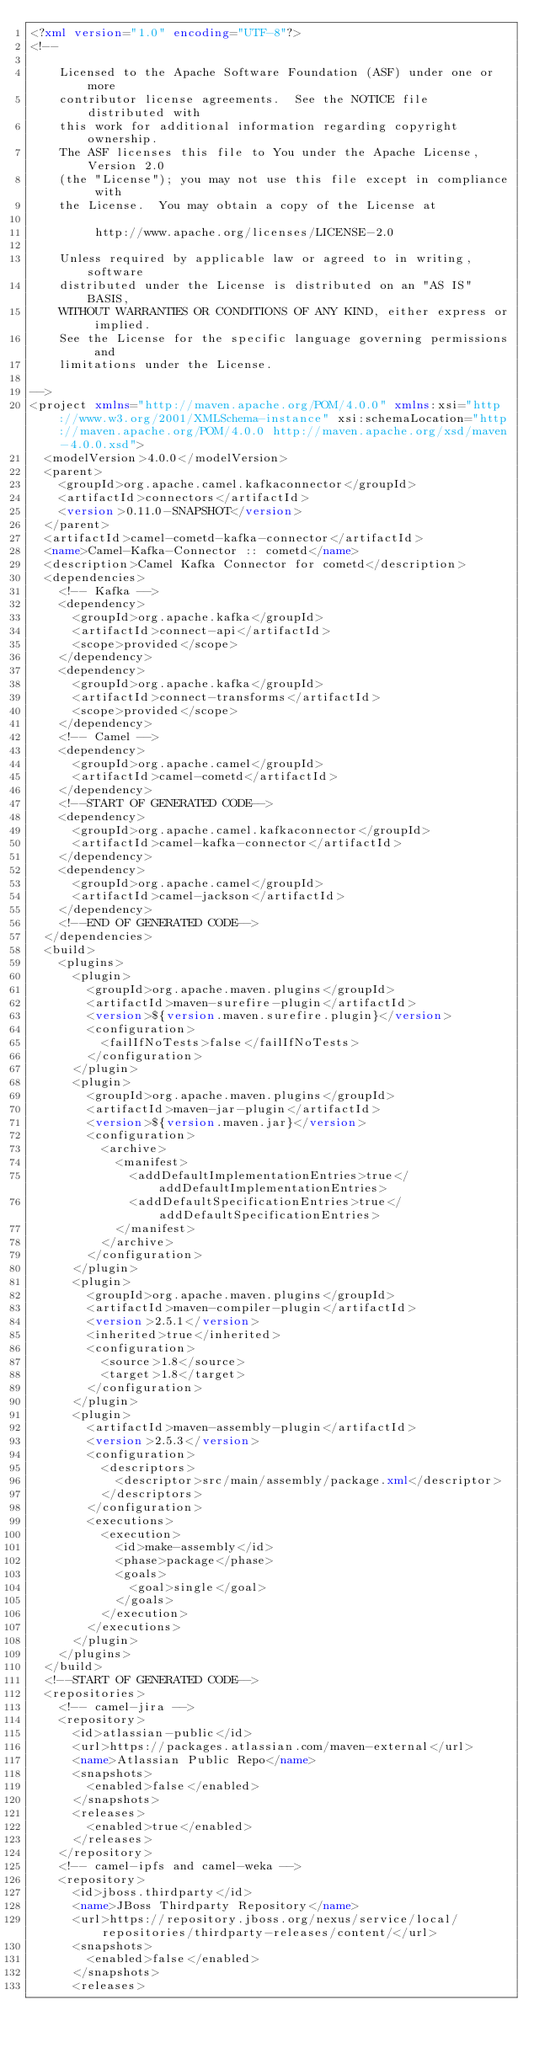Convert code to text. <code><loc_0><loc_0><loc_500><loc_500><_XML_><?xml version="1.0" encoding="UTF-8"?>
<!--

    Licensed to the Apache Software Foundation (ASF) under one or more
    contributor license agreements.  See the NOTICE file distributed with
    this work for additional information regarding copyright ownership.
    The ASF licenses this file to You under the Apache License, Version 2.0
    (the "License"); you may not use this file except in compliance with
    the License.  You may obtain a copy of the License at

         http://www.apache.org/licenses/LICENSE-2.0

    Unless required by applicable law or agreed to in writing, software
    distributed under the License is distributed on an "AS IS" BASIS,
    WITHOUT WARRANTIES OR CONDITIONS OF ANY KIND, either express or implied.
    See the License for the specific language governing permissions and
    limitations under the License.

-->
<project xmlns="http://maven.apache.org/POM/4.0.0" xmlns:xsi="http://www.w3.org/2001/XMLSchema-instance" xsi:schemaLocation="http://maven.apache.org/POM/4.0.0 http://maven.apache.org/xsd/maven-4.0.0.xsd">
  <modelVersion>4.0.0</modelVersion>
  <parent>
    <groupId>org.apache.camel.kafkaconnector</groupId>
    <artifactId>connectors</artifactId>
    <version>0.11.0-SNAPSHOT</version>
  </parent>
  <artifactId>camel-cometd-kafka-connector</artifactId>
  <name>Camel-Kafka-Connector :: cometd</name>
  <description>Camel Kafka Connector for cometd</description>
  <dependencies>
    <!-- Kafka -->
    <dependency>
      <groupId>org.apache.kafka</groupId>
      <artifactId>connect-api</artifactId>
      <scope>provided</scope>
    </dependency>
    <dependency>
      <groupId>org.apache.kafka</groupId>
      <artifactId>connect-transforms</artifactId>
      <scope>provided</scope>
    </dependency>
    <!-- Camel -->
    <dependency>
      <groupId>org.apache.camel</groupId>
      <artifactId>camel-cometd</artifactId>
    </dependency>
    <!--START OF GENERATED CODE-->
    <dependency>
      <groupId>org.apache.camel.kafkaconnector</groupId>
      <artifactId>camel-kafka-connector</artifactId>
    </dependency>
    <dependency>
      <groupId>org.apache.camel</groupId>
      <artifactId>camel-jackson</artifactId>
    </dependency>
    <!--END OF GENERATED CODE-->
  </dependencies>
  <build>
    <plugins>
      <plugin>
        <groupId>org.apache.maven.plugins</groupId>
        <artifactId>maven-surefire-plugin</artifactId>
        <version>${version.maven.surefire.plugin}</version>
        <configuration>
          <failIfNoTests>false</failIfNoTests>
        </configuration>
      </plugin>
      <plugin>
        <groupId>org.apache.maven.plugins</groupId>
        <artifactId>maven-jar-plugin</artifactId>
        <version>${version.maven.jar}</version>
        <configuration>
          <archive>
            <manifest>
              <addDefaultImplementationEntries>true</addDefaultImplementationEntries>
              <addDefaultSpecificationEntries>true</addDefaultSpecificationEntries>
            </manifest>
          </archive>
        </configuration>
      </plugin>
      <plugin>
        <groupId>org.apache.maven.plugins</groupId>
        <artifactId>maven-compiler-plugin</artifactId>
        <version>2.5.1</version>
        <inherited>true</inherited>
        <configuration>
          <source>1.8</source>
          <target>1.8</target>
        </configuration>
      </plugin>
      <plugin>
        <artifactId>maven-assembly-plugin</artifactId>
        <version>2.5.3</version>
        <configuration>
          <descriptors>
            <descriptor>src/main/assembly/package.xml</descriptor>
          </descriptors>
        </configuration>
        <executions>
          <execution>
            <id>make-assembly</id>
            <phase>package</phase>
            <goals>
              <goal>single</goal>
            </goals>
          </execution>
        </executions>
      </plugin>
    </plugins>
  </build>
  <!--START OF GENERATED CODE-->
  <repositories>
    <!-- camel-jira -->
    <repository>
      <id>atlassian-public</id>
      <url>https://packages.atlassian.com/maven-external</url>
      <name>Atlassian Public Repo</name>
      <snapshots>
        <enabled>false</enabled>
      </snapshots>
      <releases>
        <enabled>true</enabled>
      </releases>
    </repository>
    <!-- camel-ipfs and camel-weka -->
    <repository>
      <id>jboss.thirdparty</id>
      <name>JBoss Thirdparty Repository</name>
      <url>https://repository.jboss.org/nexus/service/local/repositories/thirdparty-releases/content/</url>
      <snapshots>
        <enabled>false</enabled>
      </snapshots>
      <releases></code> 